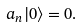Convert formula to latex. <formula><loc_0><loc_0><loc_500><loc_500>a _ { n } | 0 \rangle = 0 .</formula> 